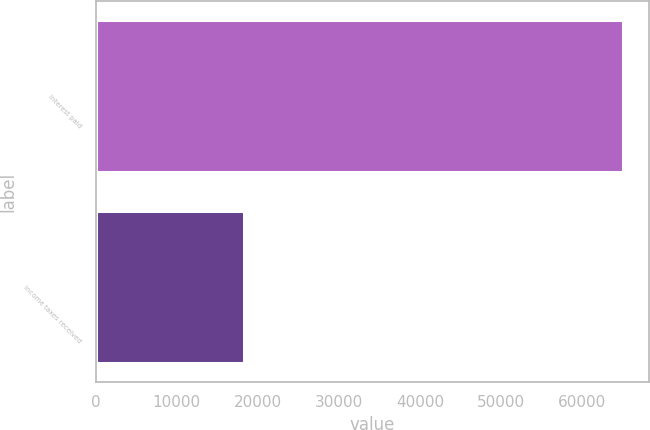<chart> <loc_0><loc_0><loc_500><loc_500><bar_chart><fcel>Interest paid<fcel>Income taxes received<nl><fcel>64997<fcel>18351<nl></chart> 